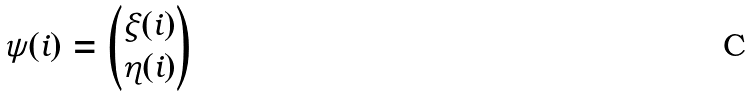Convert formula to latex. <formula><loc_0><loc_0><loc_500><loc_500>\psi ( i ) = \left ( \begin{matrix} \xi ( i ) \\ \eta ( i ) \end{matrix} \right )</formula> 